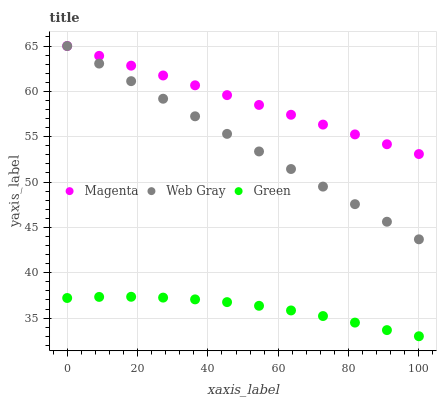Does Green have the minimum area under the curve?
Answer yes or no. Yes. Does Magenta have the maximum area under the curve?
Answer yes or no. Yes. Does Web Gray have the minimum area under the curve?
Answer yes or no. No. Does Web Gray have the maximum area under the curve?
Answer yes or no. No. Is Magenta the smoothest?
Answer yes or no. Yes. Is Green the roughest?
Answer yes or no. Yes. Is Web Gray the smoothest?
Answer yes or no. No. Is Web Gray the roughest?
Answer yes or no. No. Does Green have the lowest value?
Answer yes or no. Yes. Does Web Gray have the lowest value?
Answer yes or no. No. Does Web Gray have the highest value?
Answer yes or no. Yes. Does Green have the highest value?
Answer yes or no. No. Is Green less than Web Gray?
Answer yes or no. Yes. Is Magenta greater than Green?
Answer yes or no. Yes. Does Magenta intersect Web Gray?
Answer yes or no. Yes. Is Magenta less than Web Gray?
Answer yes or no. No. Is Magenta greater than Web Gray?
Answer yes or no. No. Does Green intersect Web Gray?
Answer yes or no. No. 